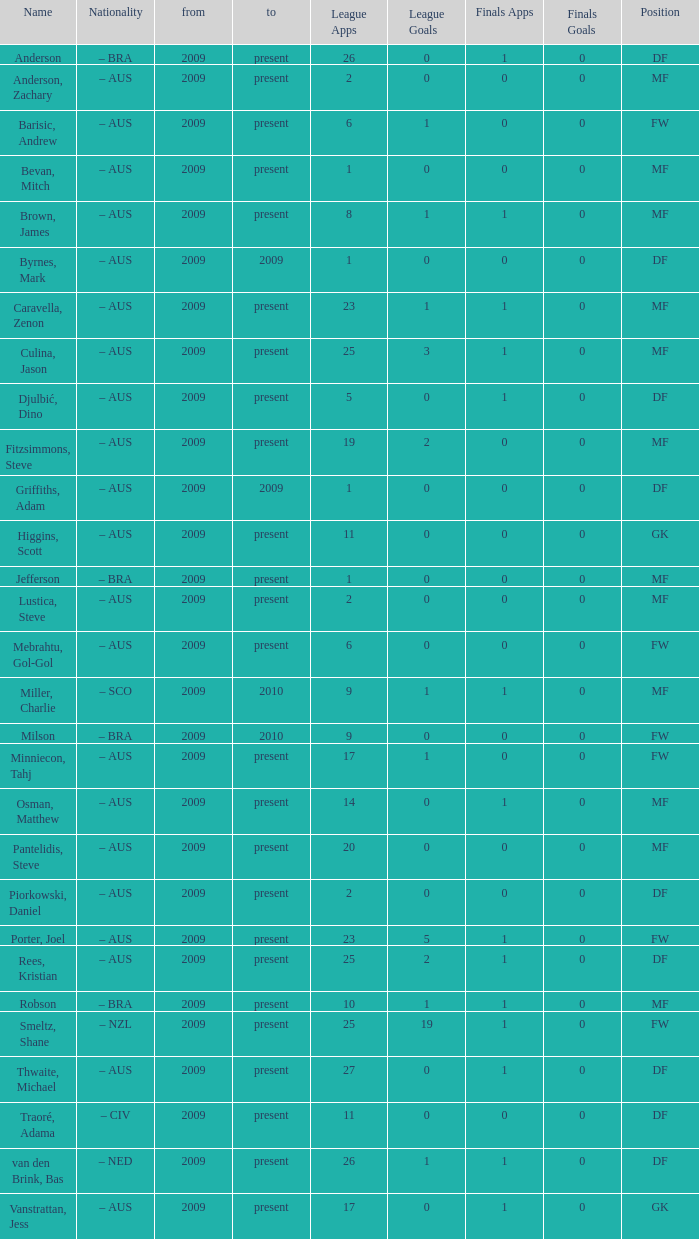Name the mosst finals apps 1.0. 